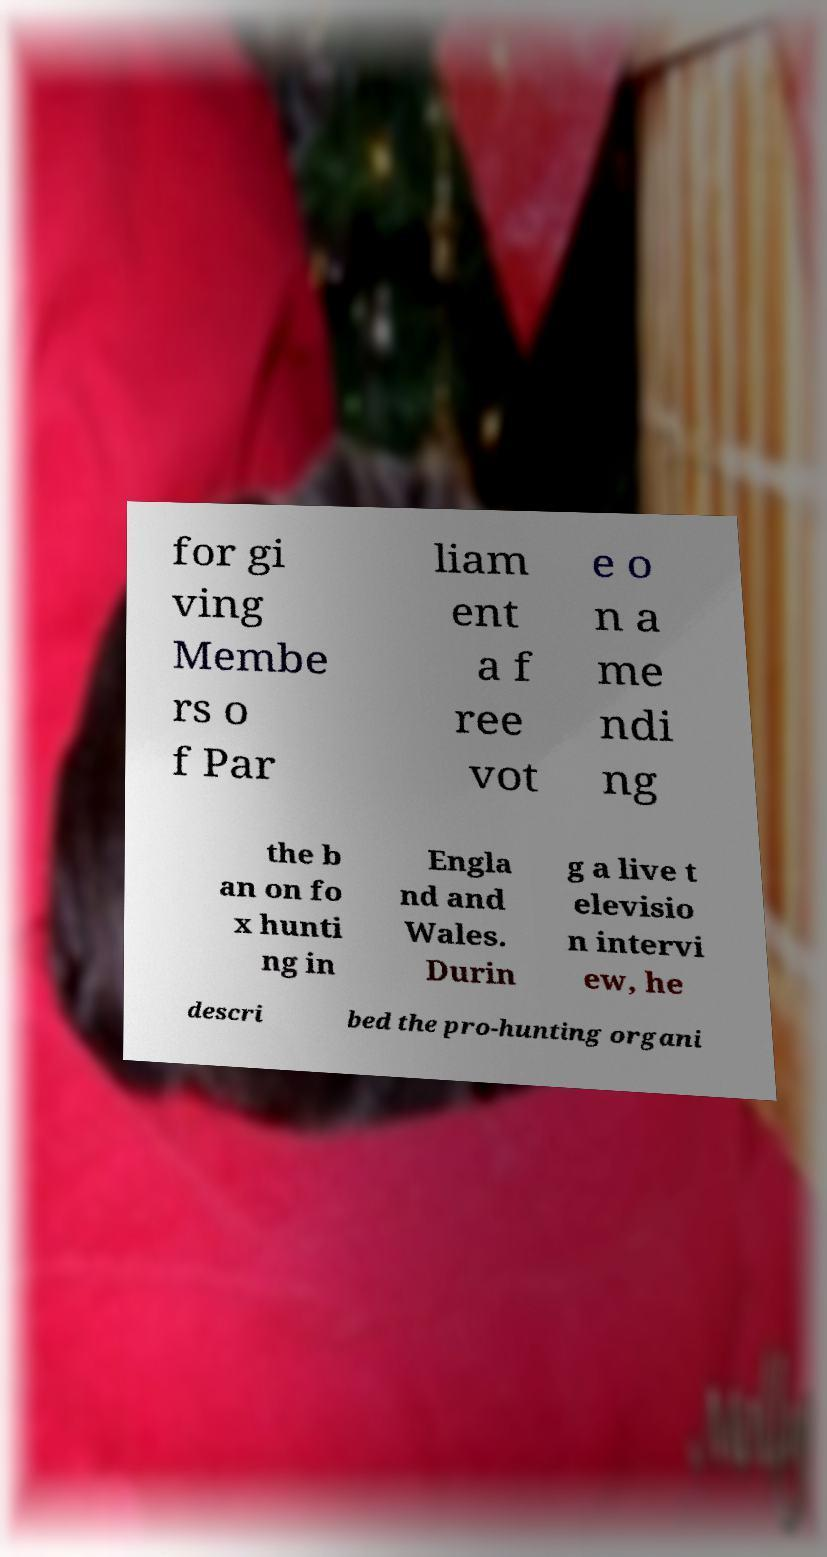Please read and relay the text visible in this image. What does it say? for gi ving Membe rs o f Par liam ent a f ree vot e o n a me ndi ng the b an on fo x hunti ng in Engla nd and Wales. Durin g a live t elevisio n intervi ew, he descri bed the pro-hunting organi 